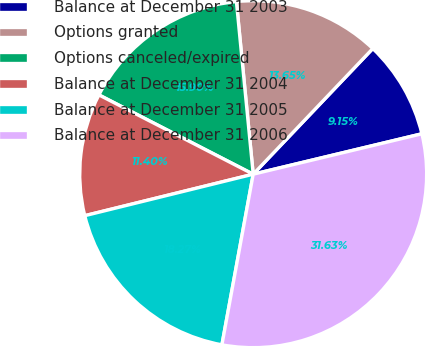Convert chart. <chart><loc_0><loc_0><loc_500><loc_500><pie_chart><fcel>Balance at December 31 2003<fcel>Options granted<fcel>Options canceled/expired<fcel>Balance at December 31 2004<fcel>Balance at December 31 2005<fcel>Balance at December 31 2006<nl><fcel>9.15%<fcel>13.65%<fcel>15.9%<fcel>11.4%<fcel>18.27%<fcel>31.63%<nl></chart> 